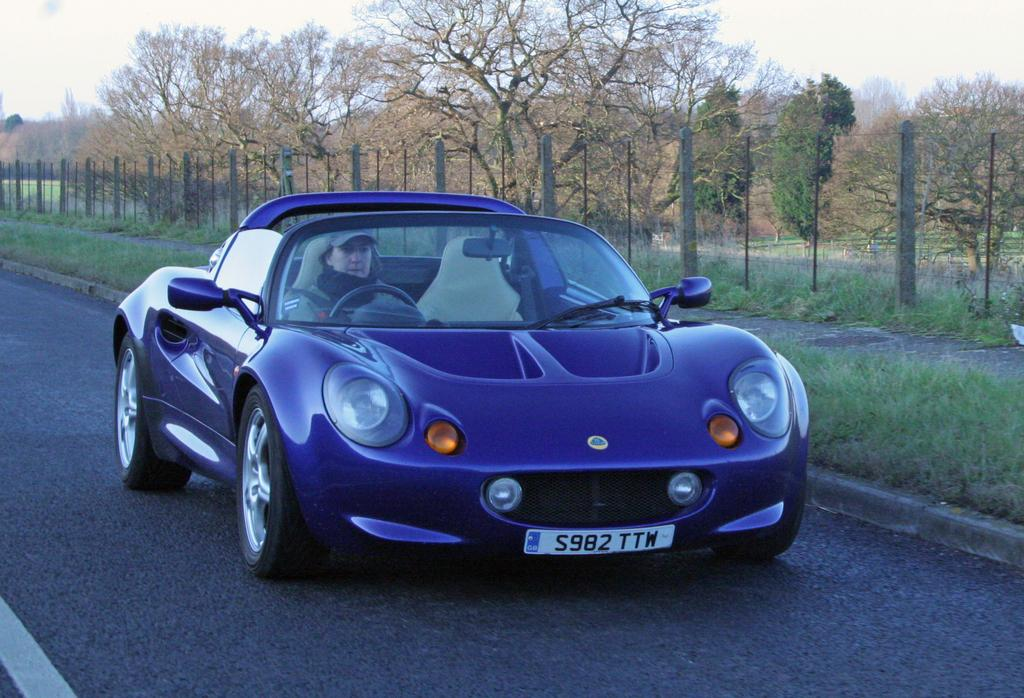What is the person in the image doing? The person is sitting in a blue car. What is the car doing in the image? The car is moving on the road. What can be seen in the background of the image? There is a fence, trees, grass, and the sky visible in the background of the image. What type of coal is being used to fuel the car in the image? There is no coal present in the image, and the car is not fueled by coal. Is the person's brother sitting in the car with them in the image? There is no information about the person's brother in the image, so it cannot be determined if they are present. 